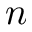Convert formula to latex. <formula><loc_0><loc_0><loc_500><loc_500>n</formula> 